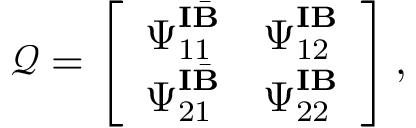<formula> <loc_0><loc_0><loc_500><loc_500>\mathcal { Q } = \left [ \begin{array} { l l } { \Psi _ { 1 1 } ^ { I \bar { B } } } & { \Psi _ { 1 2 } ^ { I B } } \\ { \Psi _ { 2 1 } ^ { I \bar { B } } } & { \Psi _ { 2 2 } ^ { I B } } \end{array} \right ] ,</formula> 